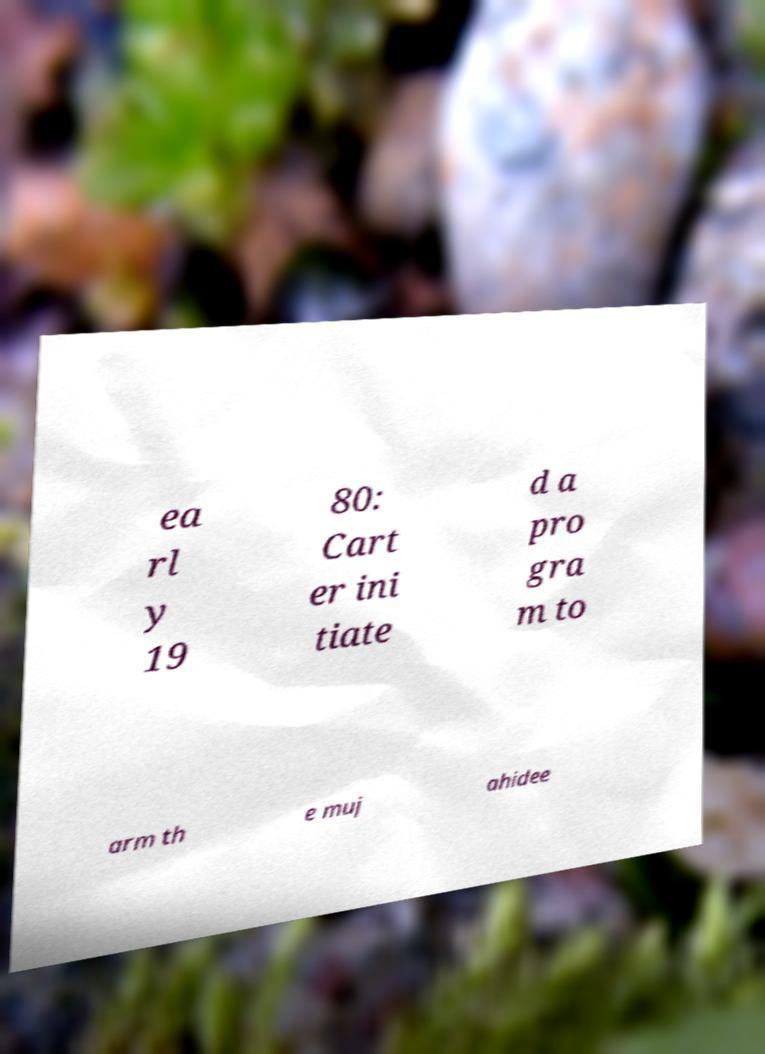Please identify and transcribe the text found in this image. ea rl y 19 80: Cart er ini tiate d a pro gra m to arm th e muj ahidee 